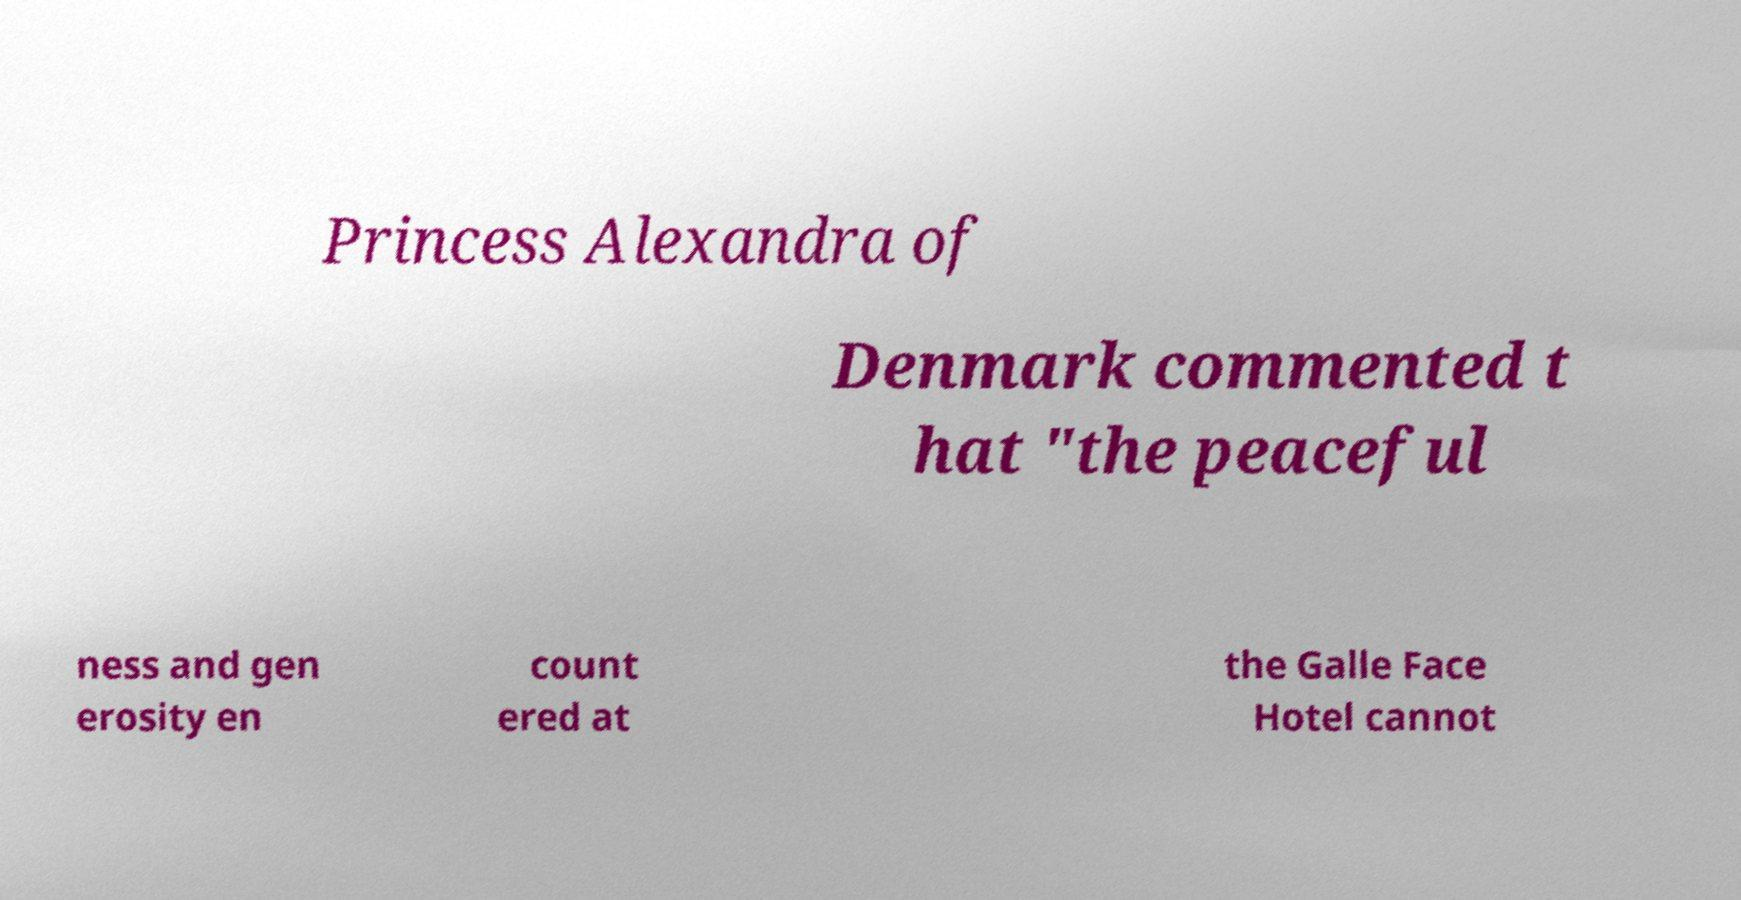Could you assist in decoding the text presented in this image and type it out clearly? Princess Alexandra of Denmark commented t hat "the peaceful ness and gen erosity en count ered at the Galle Face Hotel cannot 